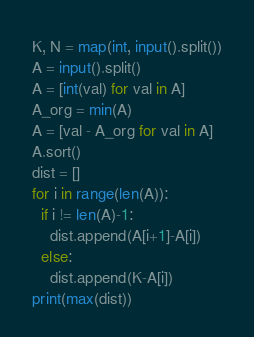<code> <loc_0><loc_0><loc_500><loc_500><_Python_>K, N = map(int, input().split())
A = input().split()
A = [int(val) for val in A]
A_org = min(A)
A = [val - A_org for val in A]
A.sort()
dist = []
for i in range(len(A)):
  if i != len(A)-1:
    dist.append(A[i+1]-A[i])
  else:
    dist.append(K-A[i])
print(max(dist))</code> 